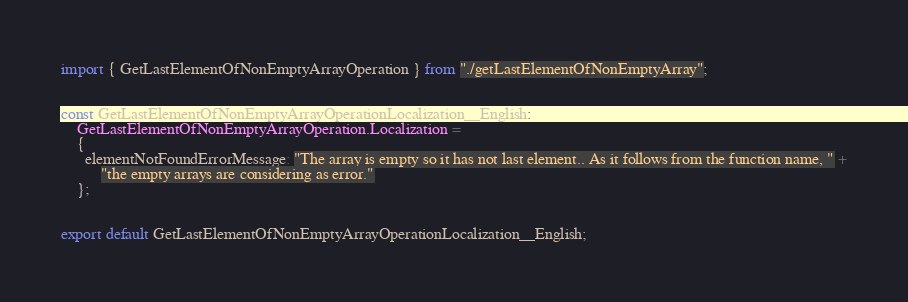<code> <loc_0><loc_0><loc_500><loc_500><_TypeScript_>import { GetLastElementOfNonEmptyArrayOperation } from "./getLastElementOfNonEmptyArray";


const GetLastElementOfNonEmptyArrayOperationLocalization__English:
    GetLastElementOfNonEmptyArrayOperation.Localization =
    {
      elementNotFoundErrorMessage: "The array is empty so it has not last element.. As it follows from the function name, " +
          "the empty arrays are considering as error."
    };


export default GetLastElementOfNonEmptyArrayOperationLocalization__English;
</code> 